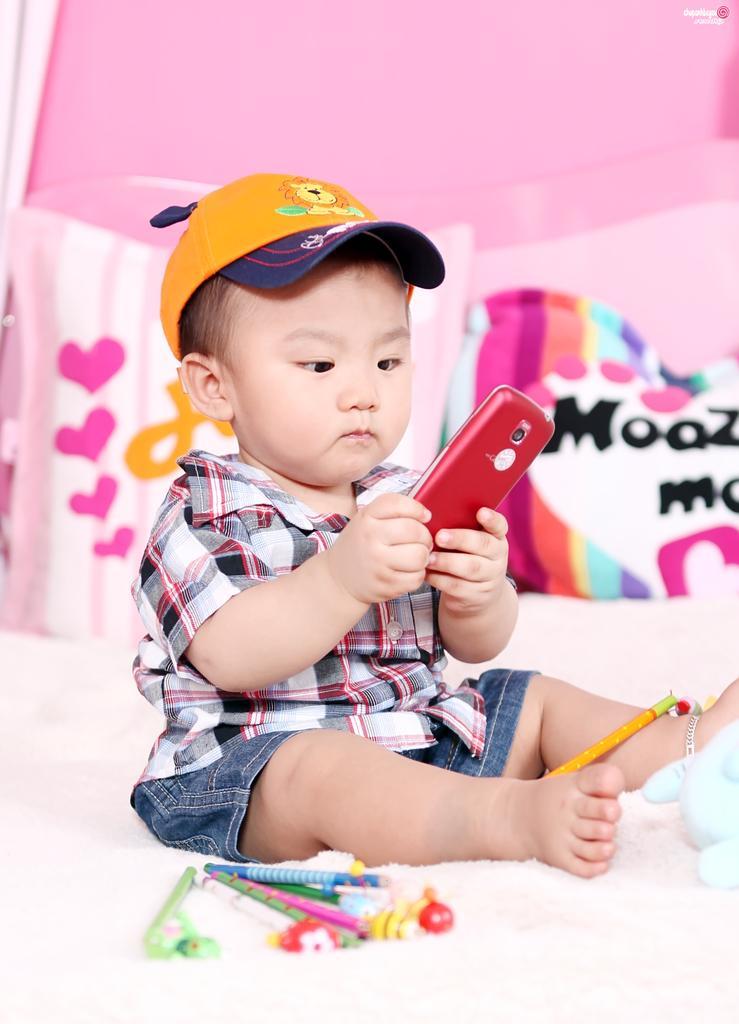How would you summarize this image in a sentence or two? This kid sitting and holding mobile and wear cap. We can see pencils and toy on the bed. Behind this kid we can see pillows. 